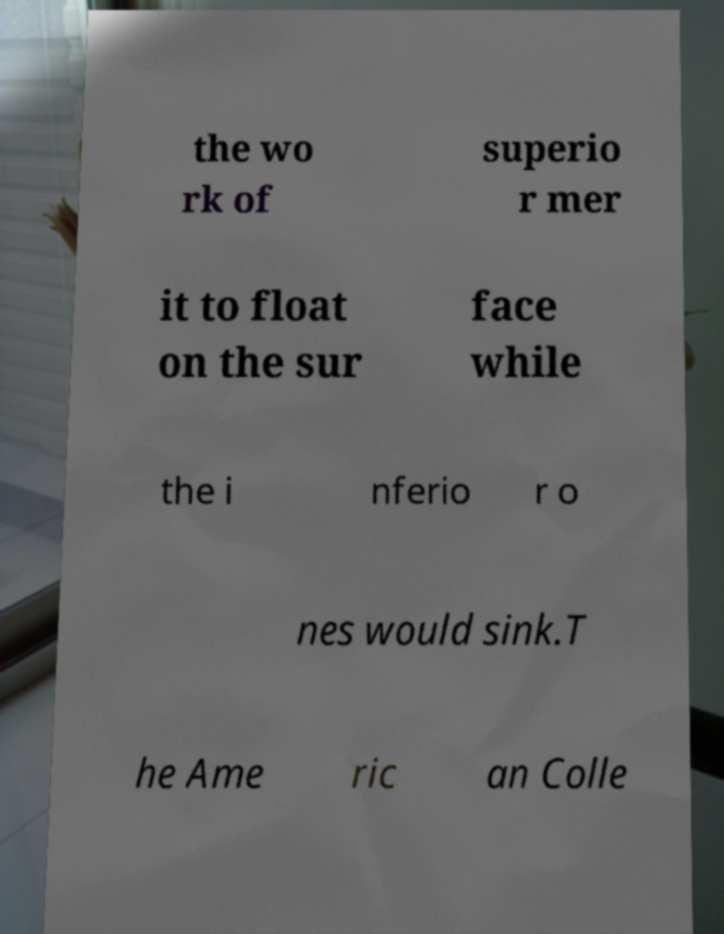Can you accurately transcribe the text from the provided image for me? the wo rk of superio r mer it to float on the sur face while the i nferio r o nes would sink.T he Ame ric an Colle 